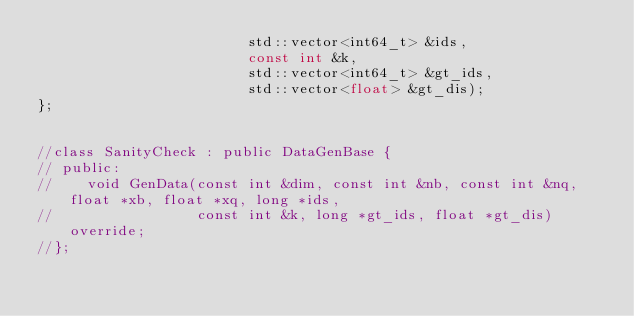<code> <loc_0><loc_0><loc_500><loc_500><_C_>                         std::vector<int64_t> &ids,
                         const int &k,
                         std::vector<int64_t> &gt_ids,
                         std::vector<float> &gt_dis);
};


//class SanityCheck : public DataGenBase {
// public:
//    void GenData(const int &dim, const int &nb, const int &nq, float *xb, float *xq, long *ids,
//                 const int &k, long *gt_ids, float *gt_dis) override;
//};

</code> 